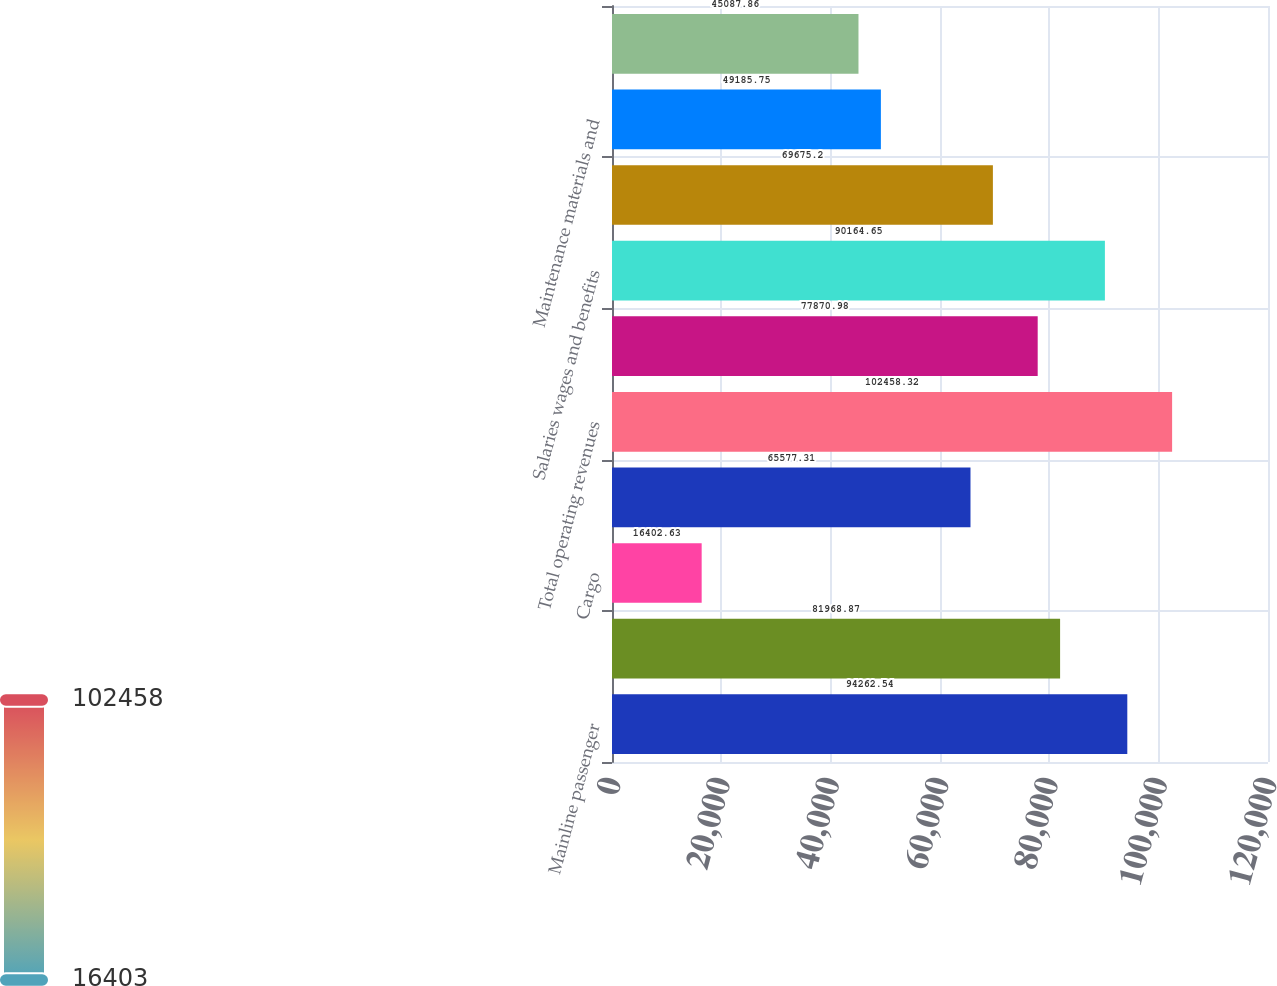Convert chart to OTSL. <chart><loc_0><loc_0><loc_500><loc_500><bar_chart><fcel>Mainline passenger<fcel>Regional passenger<fcel>Cargo<fcel>Other<fcel>Total operating revenues<fcel>Aircraft fuel and related<fcel>Salaries wages and benefits<fcel>Regional expenses<fcel>Maintenance materials and<fcel>Other rent and landing fees<nl><fcel>94262.5<fcel>81968.9<fcel>16402.6<fcel>65577.3<fcel>102458<fcel>77871<fcel>90164.6<fcel>69675.2<fcel>49185.8<fcel>45087.9<nl></chart> 